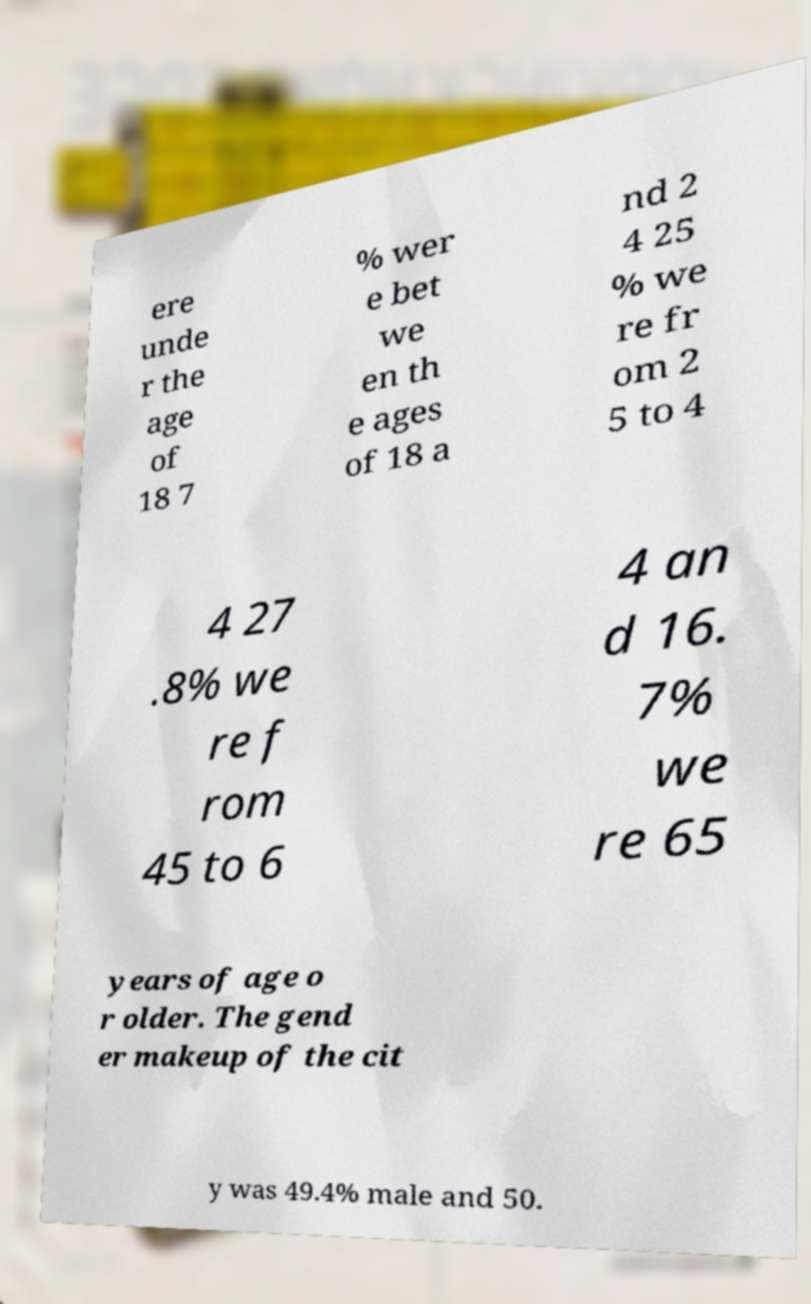There's text embedded in this image that I need extracted. Can you transcribe it verbatim? ere unde r the age of 18 7 % wer e bet we en th e ages of 18 a nd 2 4 25 % we re fr om 2 5 to 4 4 27 .8% we re f rom 45 to 6 4 an d 16. 7% we re 65 years of age o r older. The gend er makeup of the cit y was 49.4% male and 50. 